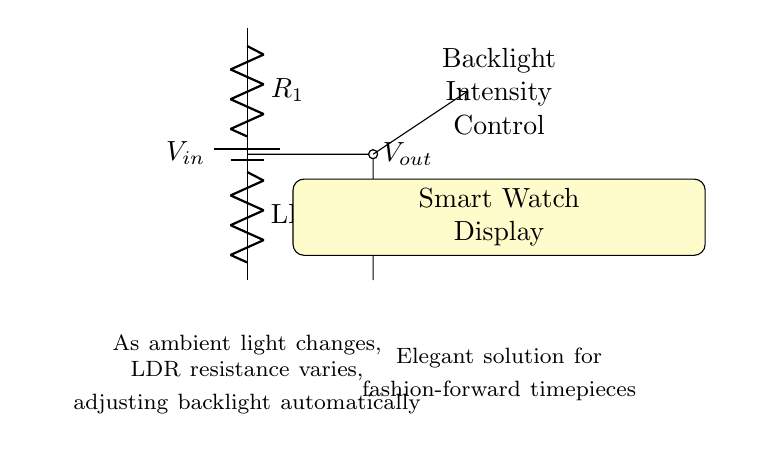What is the input voltage in the circuit? The circuit indicates an input voltage labeled as V_in at the battery symbol; this is the voltage supplied to the circuit.
Answer: V_in What type of resistor is indicated as R_1? In the circuit, R_1 is labeled simply as a resistor, indicating a fixed resistance component which is commonly used to form a voltage divider.
Answer: Resistor How does the light-dependent resistor function in the circuit? The circuit shows an LDR (light-dependent resistor) connected underneath R_1; its resistance changes with ambient light levels, affecting the output voltage.
Answer: Changes with light What is the purpose of the V_out node in this circuit? V_out is the point where the output voltage is measured; it reflects the voltage across the LDR and thus varies with light intensity, which is crucial for controlling backlight.
Answer: Output voltage What happens to the backlight intensity when ambient light increases? As ambient light increases, the resistance of the LDR decreases, increasing V_out, which leads to a higher backlight intensity being applied to the smart watch display.
Answer: Increases Explain the relationship between R_1 and the LDR in this voltage divider circuit. In this voltage divider, R_1 and the LDR work together, where the voltage V_out is dependent on their resistances; V_out is calculated by the ratio of these resistances and the input voltage, creating a dynamic control circuit for the backlight.
Answer: Voltage divider relationship 